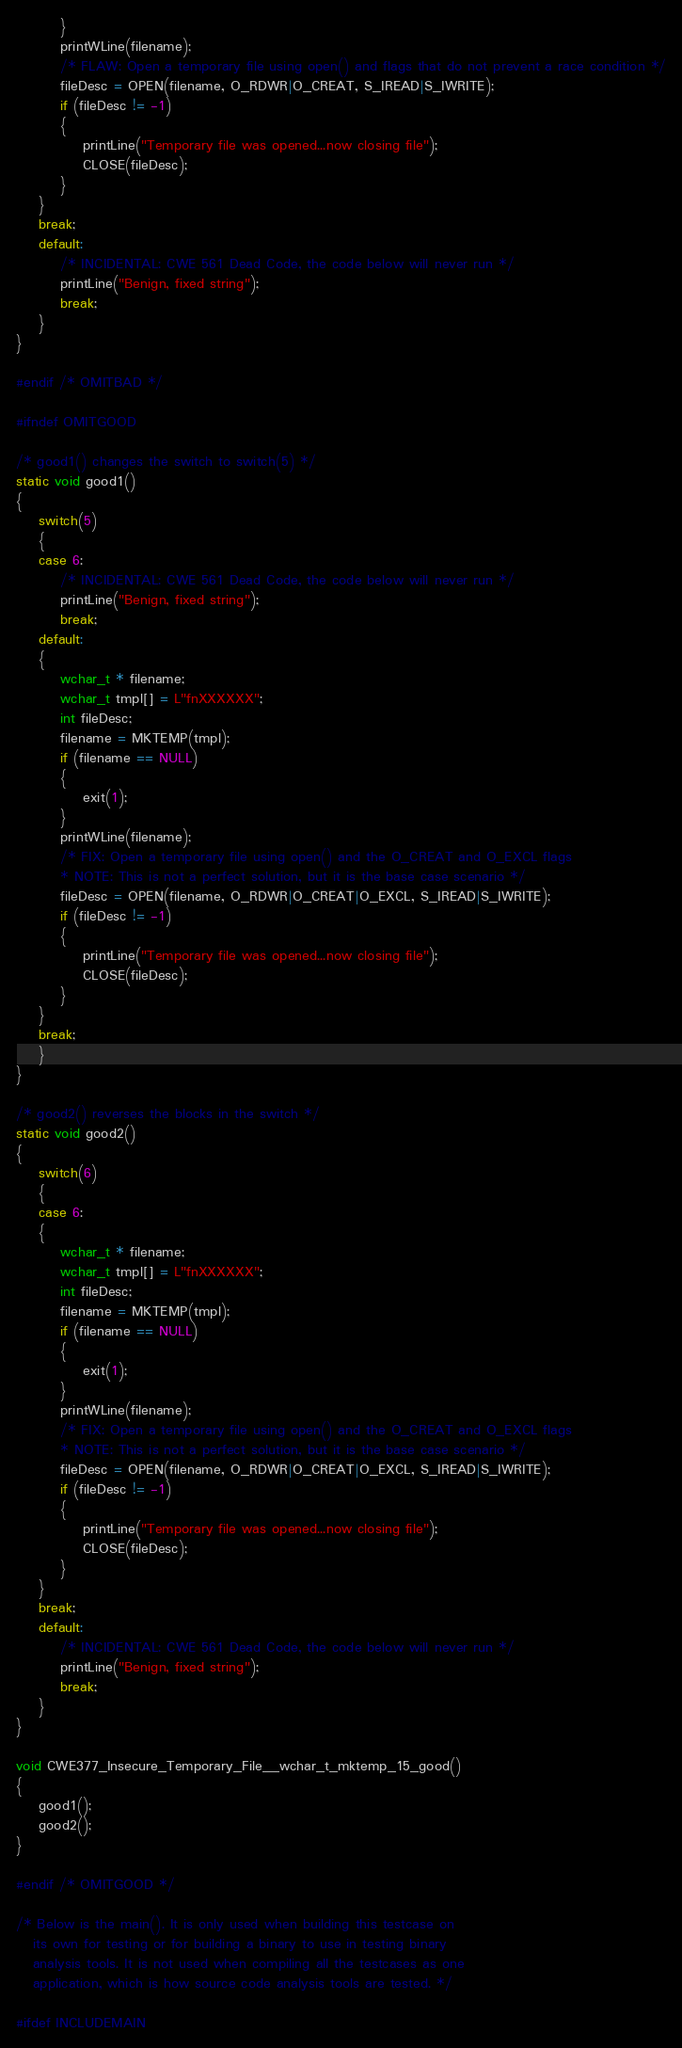Convert code to text. <code><loc_0><loc_0><loc_500><loc_500><_C_>        }
        printWLine(filename);
        /* FLAW: Open a temporary file using open() and flags that do not prevent a race condition */
        fileDesc = OPEN(filename, O_RDWR|O_CREAT, S_IREAD|S_IWRITE);
        if (fileDesc != -1)
        {
            printLine("Temporary file was opened...now closing file");
            CLOSE(fileDesc);
        }
    }
    break;
    default:
        /* INCIDENTAL: CWE 561 Dead Code, the code below will never run */
        printLine("Benign, fixed string");
        break;
    }
}

#endif /* OMITBAD */

#ifndef OMITGOOD

/* good1() changes the switch to switch(5) */
static void good1()
{
    switch(5)
    {
    case 6:
        /* INCIDENTAL: CWE 561 Dead Code, the code below will never run */
        printLine("Benign, fixed string");
        break;
    default:
    {
        wchar_t * filename;
        wchar_t tmpl[] = L"fnXXXXXX";
        int fileDesc;
        filename = MKTEMP(tmpl);
        if (filename == NULL)
        {
            exit(1);
        }
        printWLine(filename);
        /* FIX: Open a temporary file using open() and the O_CREAT and O_EXCL flags
        * NOTE: This is not a perfect solution, but it is the base case scenario */
        fileDesc = OPEN(filename, O_RDWR|O_CREAT|O_EXCL, S_IREAD|S_IWRITE);
        if (fileDesc != -1)
        {
            printLine("Temporary file was opened...now closing file");
            CLOSE(fileDesc);
        }
    }
    break;
    }
}

/* good2() reverses the blocks in the switch */
static void good2()
{
    switch(6)
    {
    case 6:
    {
        wchar_t * filename;
        wchar_t tmpl[] = L"fnXXXXXX";
        int fileDesc;
        filename = MKTEMP(tmpl);
        if (filename == NULL)
        {
            exit(1);
        }
        printWLine(filename);
        /* FIX: Open a temporary file using open() and the O_CREAT and O_EXCL flags
        * NOTE: This is not a perfect solution, but it is the base case scenario */
        fileDesc = OPEN(filename, O_RDWR|O_CREAT|O_EXCL, S_IREAD|S_IWRITE);
        if (fileDesc != -1)
        {
            printLine("Temporary file was opened...now closing file");
            CLOSE(fileDesc);
        }
    }
    break;
    default:
        /* INCIDENTAL: CWE 561 Dead Code, the code below will never run */
        printLine("Benign, fixed string");
        break;
    }
}

void CWE377_Insecure_Temporary_File__wchar_t_mktemp_15_good()
{
    good1();
    good2();
}

#endif /* OMITGOOD */

/* Below is the main(). It is only used when building this testcase on
   its own for testing or for building a binary to use in testing binary
   analysis tools. It is not used when compiling all the testcases as one
   application, which is how source code analysis tools are tested. */

#ifdef INCLUDEMAIN
</code> 